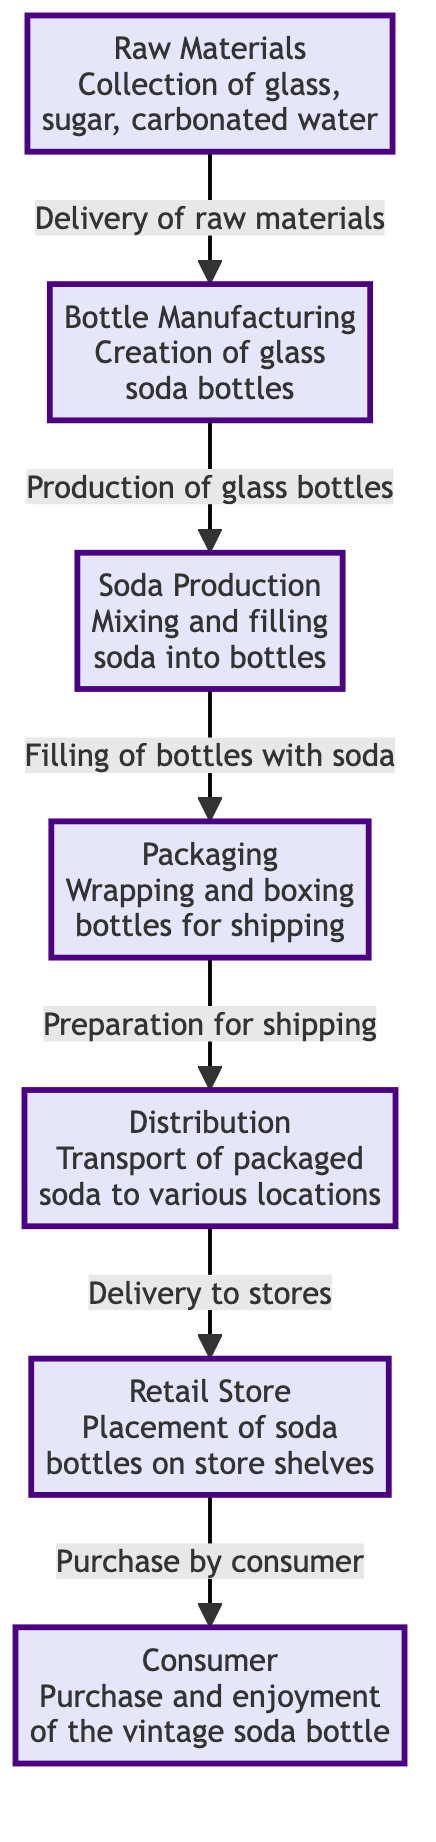What are the raw materials used in the vintage soda production? The diagram specifies that the raw materials include glass, sugar, and carbonated water. These are essential components for creating the soda bottles and the soda itself.
Answer: glass, sugar, carbonated water What is the first step in the journey of a vintage soda bottle? According to the diagram, the first step is the collection of raw materials. This establishes the foundation for the production chain.
Answer: Raw Materials How many steps are there in the food chain diagram? The diagram shows six distinct steps from raw materials to consumer. By counting each node, we confirm the total number of steps involved.
Answer: 6 What node follows bottle manufacturing in the production process? After the bottle manufacturing step, the next step is soda production, where the bottles are filled with the soda. This shows the flow of the process in sequence.
Answer: Soda Production What happens during the packaging step? The packaging node describes the activity of wrapping and boxing bottles for shipping, which prepares the bottles for distribution to stores. This focus on preparations highlights its role in the overall process.
Answer: Wrapping and boxing What is the final stage before the consumer gets the vintage soda bottle? Before reaching the consumer, the final stage in the diagram is the retail store, where the bottled sodas are placed on store shelves for purchase. This indicates the last point before consumption.
Answer: Retail Store How do the raw materials move to the bottle manufacturing step? The movement from raw materials to bottle manufacturing occurs through the delivery of raw materials, which shows how each part of the process depends on the previous step to function properly.
Answer: Delivery of raw materials Which node involves the actual mixing of ingredients? The soda production node is where the actual mixing and filling of soda into bottles occurs. This node is critical as it creates the final product before packaging.
Answer: Soda Production Which two steps come directly before consumer purchase? The two steps that come immediately before consumer purchase are the retail store and distribution. Distribution involves transporting the packaged soda to retail, which is then purchased by the consumer.
Answer: Distribution and Retail Store 